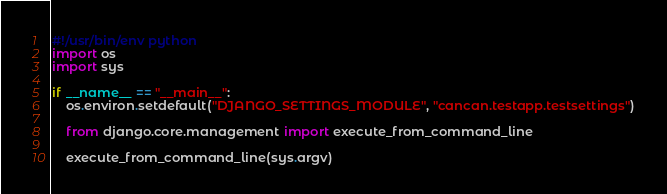Convert code to text. <code><loc_0><loc_0><loc_500><loc_500><_Python_>#!/usr/bin/env python
import os
import sys

if __name__ == "__main__":
    os.environ.setdefault("DJANGO_SETTINGS_MODULE", "cancan.testapp.testsettings")

    from django.core.management import execute_from_command_line

    execute_from_command_line(sys.argv)
</code> 